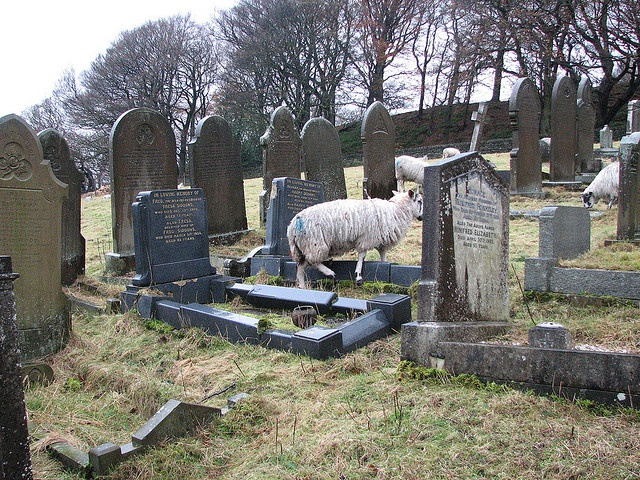Describe the objects in this image and their specific colors. I can see sheep in white, lightgray, darkgray, gray, and black tones, sheep in white, lightgray, darkgray, gray, and black tones, sheep in white, lightgray, darkgray, and gray tones, and sheep in white, darkgray, and gray tones in this image. 